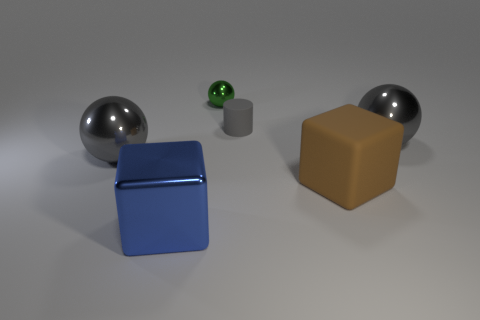There is a gray shiny object on the left side of the large gray metallic ball that is behind the thing that is to the left of the blue shiny block; what is its shape?
Your response must be concise. Sphere. What shape is the tiny metallic thing?
Give a very brief answer. Sphere. What shape is the brown rubber thing that is the same size as the blue block?
Keep it short and to the point. Cube. What number of other things are the same color as the small matte object?
Provide a succinct answer. 2. Is the shape of the thing in front of the large rubber object the same as the tiny thing that is to the left of the gray rubber thing?
Make the answer very short. No. How many objects are gray things that are right of the brown rubber object or shiny balls that are to the left of the big blue thing?
Provide a succinct answer. 2. What number of other things are there of the same material as the tiny cylinder
Offer a terse response. 1. Is the small thing that is right of the small metallic thing made of the same material as the tiny green thing?
Offer a terse response. No. Is the number of small things to the right of the green object greater than the number of spheres that are left of the brown cube?
Keep it short and to the point. No. How many objects are big things left of the matte cube or brown matte cubes?
Provide a short and direct response. 3. 